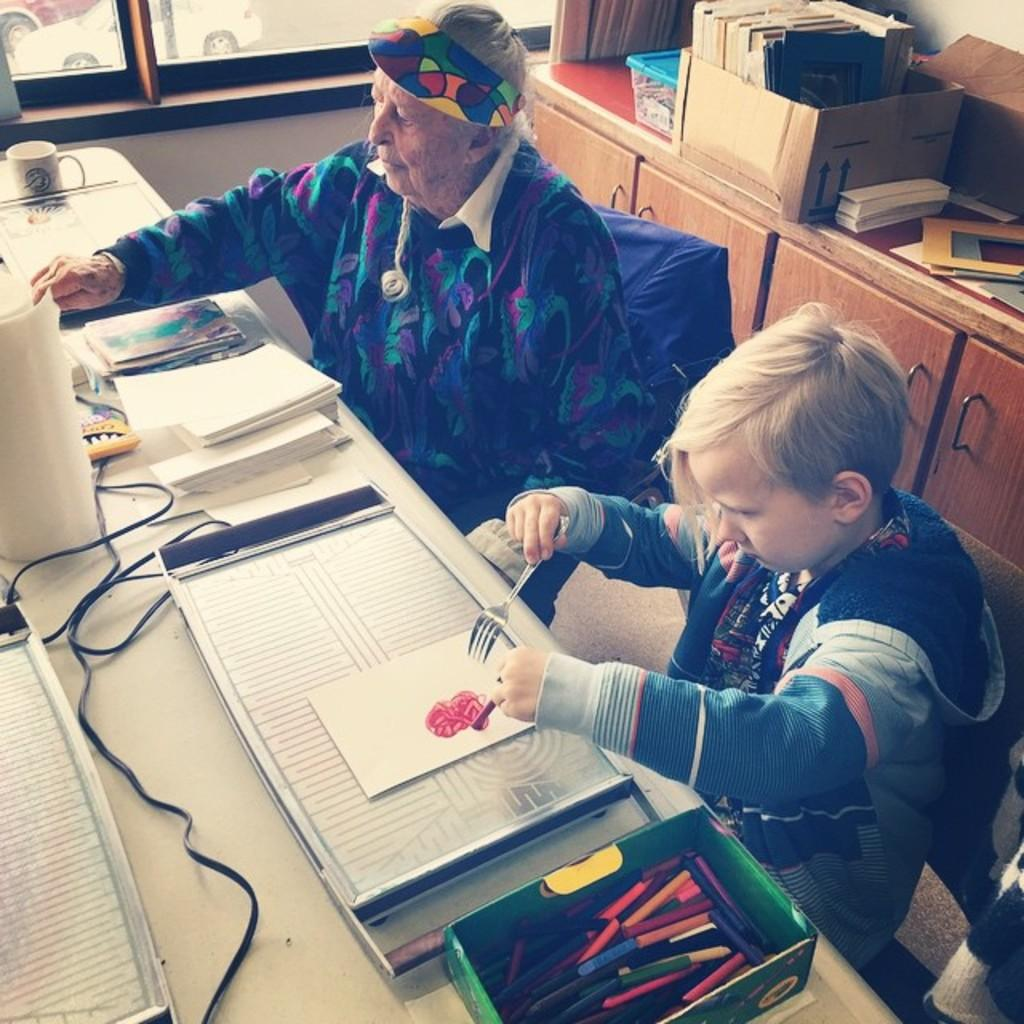What can be seen in the image that provides a view of the outside? There is a window in the image that provides a view of the outside. What are the people in the image doing? The people in the image are sitting on chairs. What is on the table in the image? There are boxes, papers, books, a wire, and a cup on the table in the image. How is the sweater being distributed among the people in the image? There is no sweater present in the image. What type of baseball equipment can be seen in the image? There is no baseball equipment present in the image. 